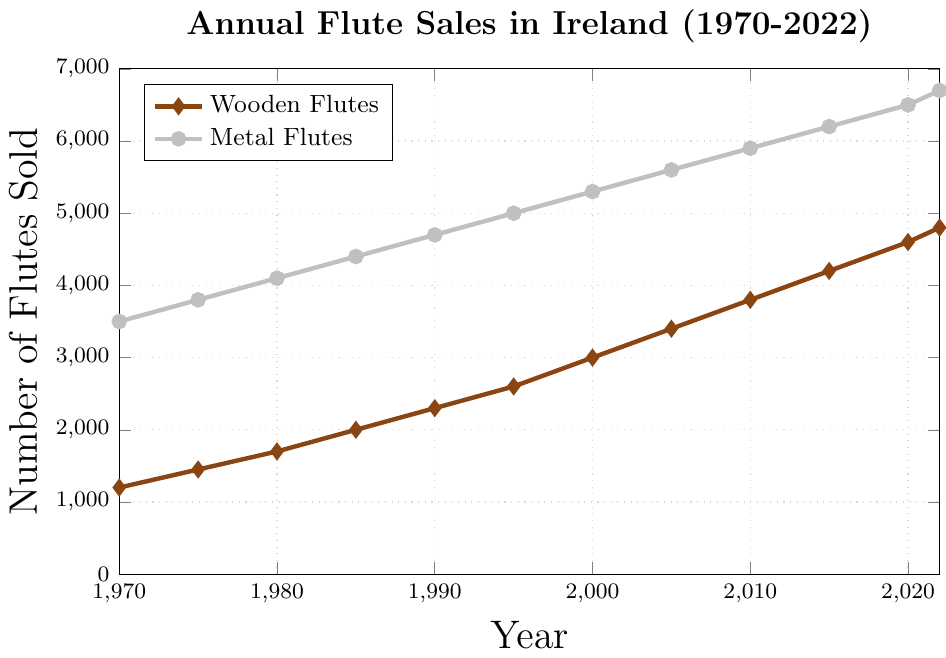How have the sales trends for wooden and metal flutes differed from 1970 to 2022? Over the years, the sales of both wooden and metal flutes have increased. However, metal flutes have consistently sold more units than wooden flutes. This difference in volume has remained relatively steady, but the gap has slightly narrowed over the years.
Answer: Metal flutes have consistently sold more, but the gap is narrowing What is the overall percentage increase in sales for wooden flutes from 1970 to 2022? The sales of wooden flutes in 1970 were 1200 and in 2022 are 4800. The percentage increase can be calculated as (4800 - 1200) / 1200 * 100%.
Answer: 300% By how much did the sales of metal flutes increase from 1970 to 2022? Sales of metal flutes were 3500 in 1970 and 6700 in 2022. The increase can be calculated as 6700 - 3500.
Answer: 3200 In which year did wooden flute sales reach half the annual sales of metal flutes for that year? In 2010, wooden flute sales were at 3800, while metal flute sales were at 5900. Half of 5900 is 2950, which wooden flutes surpassed in 2000 but were closest to in 2010.
Answer: 2010 How many more metal flutes were sold than wooden flutes in the year 2000? In 2000, the sales of metal flutes were 5300 and wooden flutes were 3000. The difference is 5300 - 3000.
Answer: 2300 Compare the trend of wooden flute sales from 1990 to 2000 with metal flute sales in the same period. Which grew more rapidly? From 1990 to 2000, wooden flute sales increased from 2300 to 3000, an increase of 700 units. Metal flute sales increased from 4700 to 5300, an increase of 600 units. Hence, wooden flute sales grew more rapidly.
Answer: Wooden flutes What is the average annual sales of metal flutes from 1970 to 2022? Sum the sales of metal flutes over all the years and divide by the number of years. (3500 + 3800 + 4100 + 4400 + 4700 + 5000 + 5300 + 5600 + 5900 + 6200 + 6500 + 6700) / 12.
Answer: 5025 Which type of flute experienced the highest growth in sales between any two consecutive points in time? Compare the differences between consecutive years for both types of flutes. The largest difference for wooden flutes is between 2015 and 2020 (4600 - 4200 = 400) and for metal flutes between 2015 and 2020 (6500 - 6200 = 300). Hence, wooden flutes experienced the highest growth.
Answer: Wooden flutes By how much did the number of wooden flute sales in 2022 exceed the number of wooden flute sales in 1970? Wooden flute sales were 4800 in 2022 and 1200 in 1970. The difference is 4800 - 1200.
Answer: 3600 What is the slope of the trend line for metal flute sales from 2000 to 2022? To find the slope, we need to calculate the change in sales per year. The sales in 2000 were 5300 and in 2022 were 6700. The change is 6700 - 5300 = 1400 over 22 years. Hence, the slope is 1400 / 22.
Answer: 63.64 